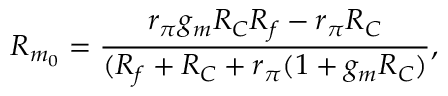<formula> <loc_0><loc_0><loc_500><loc_500>R _ { m _ { 0 } } = \frac { r _ { \pi } g _ { m } R _ { C } R _ { f } - r _ { \pi } R _ { C } } { ( R _ { f } + R _ { C } + r _ { \pi } ( 1 + g _ { m } R _ { C } ) } ,</formula> 